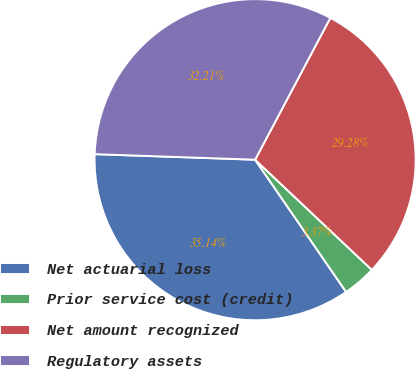Convert chart to OTSL. <chart><loc_0><loc_0><loc_500><loc_500><pie_chart><fcel>Net actuarial loss<fcel>Prior service cost (credit)<fcel>Net amount recognized<fcel>Regulatory assets<nl><fcel>35.14%<fcel>3.37%<fcel>29.28%<fcel>32.21%<nl></chart> 